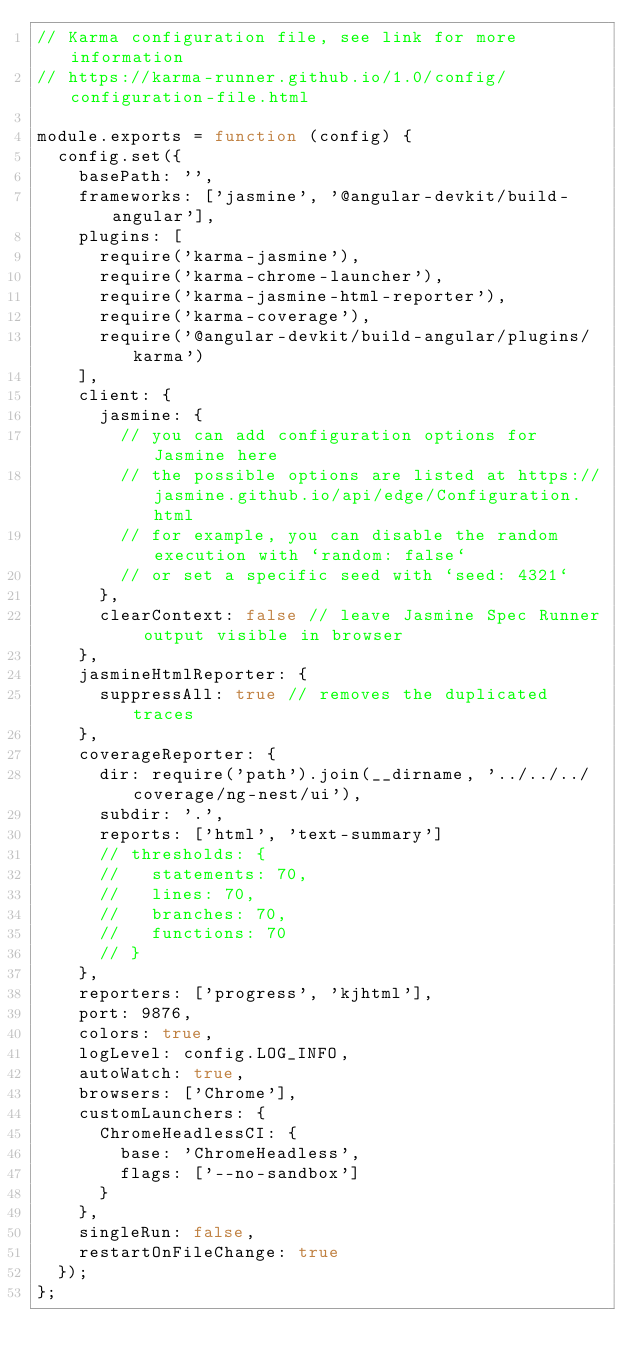<code> <loc_0><loc_0><loc_500><loc_500><_JavaScript_>// Karma configuration file, see link for more information
// https://karma-runner.github.io/1.0/config/configuration-file.html

module.exports = function (config) {
  config.set({
    basePath: '',
    frameworks: ['jasmine', '@angular-devkit/build-angular'],
    plugins: [
      require('karma-jasmine'),
      require('karma-chrome-launcher'),
      require('karma-jasmine-html-reporter'),
      require('karma-coverage'),
      require('@angular-devkit/build-angular/plugins/karma')
    ],
    client: {
      jasmine: {
        // you can add configuration options for Jasmine here
        // the possible options are listed at https://jasmine.github.io/api/edge/Configuration.html
        // for example, you can disable the random execution with `random: false`
        // or set a specific seed with `seed: 4321`
      },
      clearContext: false // leave Jasmine Spec Runner output visible in browser
    },
    jasmineHtmlReporter: {
      suppressAll: true // removes the duplicated traces
    },
    coverageReporter: {
      dir: require('path').join(__dirname, '../../../coverage/ng-nest/ui'),
      subdir: '.',
      reports: ['html', 'text-summary']
      // thresholds: {
      //   statements: 70,
      //   lines: 70,
      //   branches: 70,
      //   functions: 70
      // }
    },
    reporters: ['progress', 'kjhtml'],
    port: 9876,
    colors: true,
    logLevel: config.LOG_INFO,
    autoWatch: true,
    browsers: ['Chrome'],
    customLaunchers: {
      ChromeHeadlessCI: {
        base: 'ChromeHeadless',
        flags: ['--no-sandbox']
      }
    },
    singleRun: false,
    restartOnFileChange: true
  });
};
</code> 